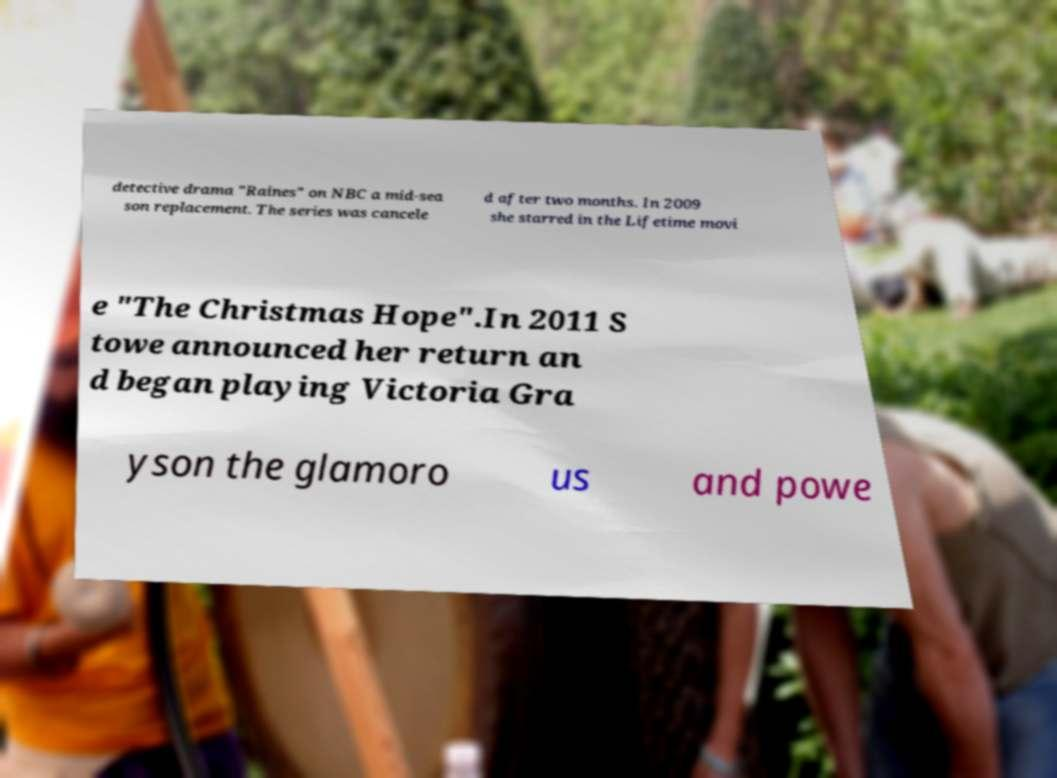There's text embedded in this image that I need extracted. Can you transcribe it verbatim? detective drama "Raines" on NBC a mid-sea son replacement. The series was cancele d after two months. In 2009 she starred in the Lifetime movi e "The Christmas Hope".In 2011 S towe announced her return an d began playing Victoria Gra yson the glamoro us and powe 